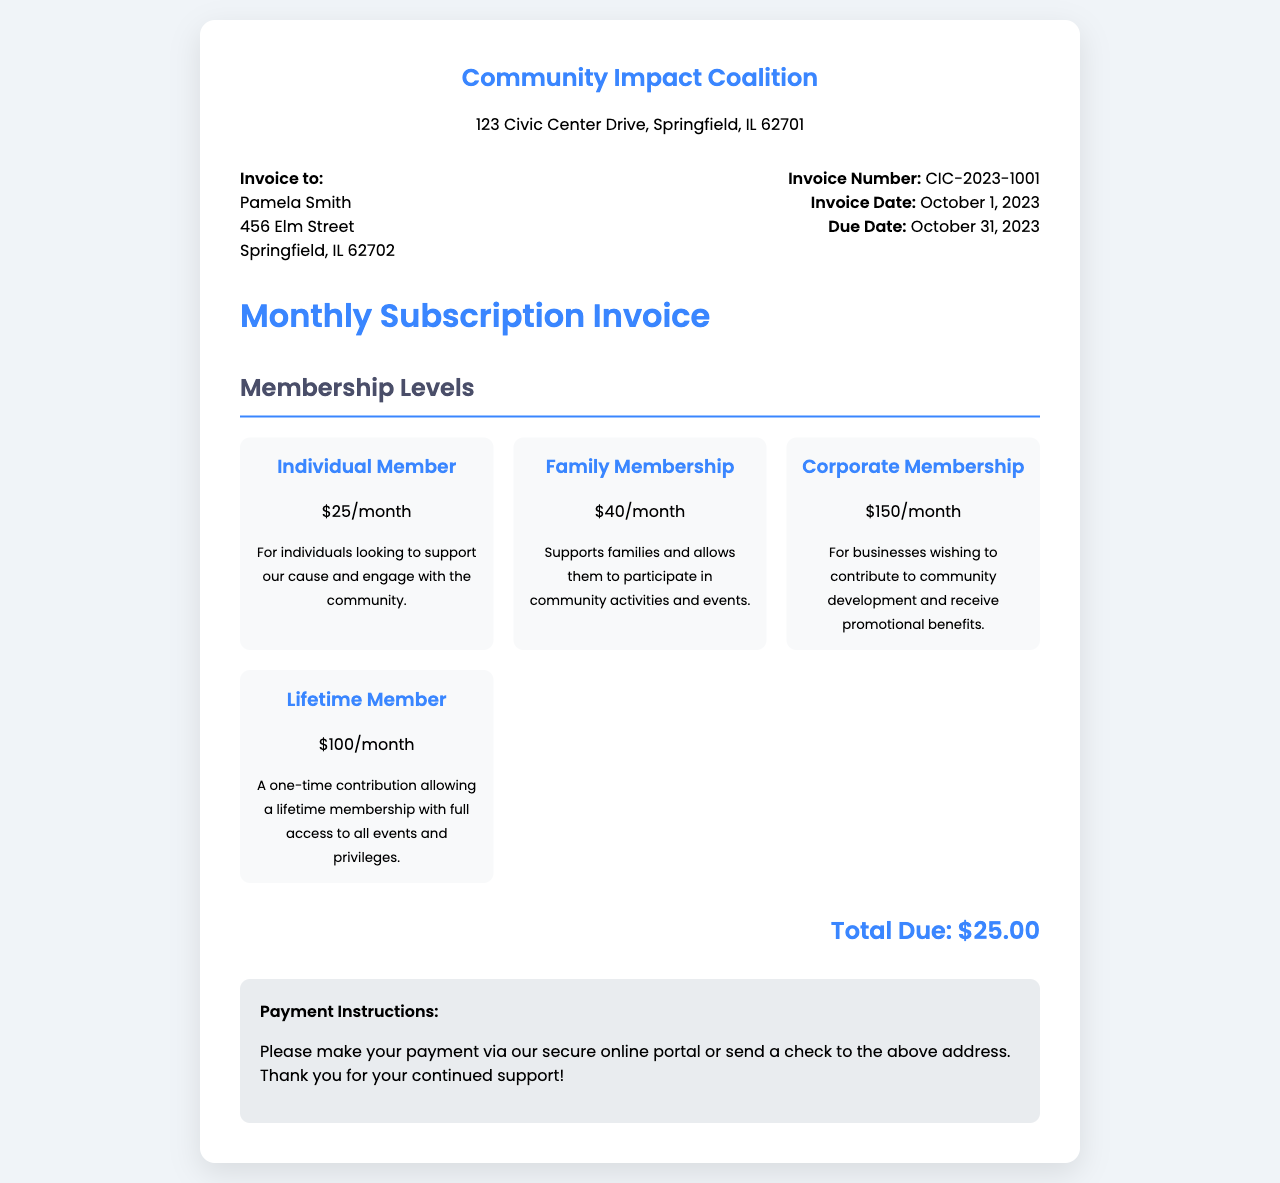What is the invoice number? The invoice number is a unique identifier for this invoice. It can be found under the 'Invoice Number' section.
Answer: CIC-2023-1001 Who is the invoice addressed to? The recipient of the invoice is mentioned in the 'Invoice to' section at the top of the document.
Answer: Pamela Smith What is the total due amount? The total amount that needs to be paid is specified at the bottom of the invoice.
Answer: $25.00 What is the monthly cost of an Individual Member? The cost for an Individual Membership is stated in the Membership Levels section.
Answer: $25/month When is the due date for this invoice? The due date is listed in the 'Invoice Date' section and indicates when payment is required.
Answer: October 31, 2023 Which membership level offers full access to events and privileges? This information is derived from the description provided in the Membership Levels section.
Answer: Lifetime Member What is the payment method specified in the document? The preferred method for making payment is outlined in the Payment Instructions section.
Answer: Online portal or check What is the address of the Community Impact Coalition? The address of the organization is shown in the header of the document.
Answer: 123 Civic Center Drive, Springfield, IL 62701 